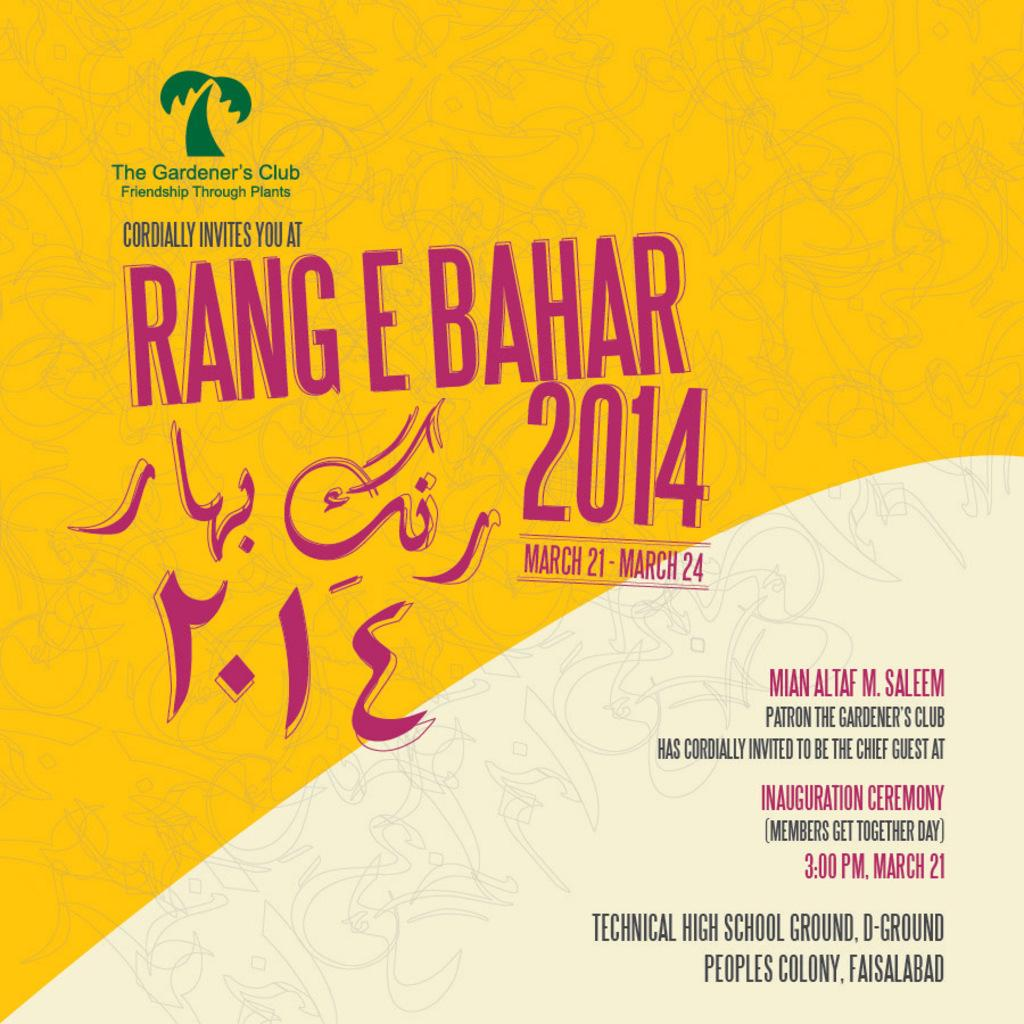<image>
Share a concise interpretation of the image provided. an advertisement with the year 2014 on it 